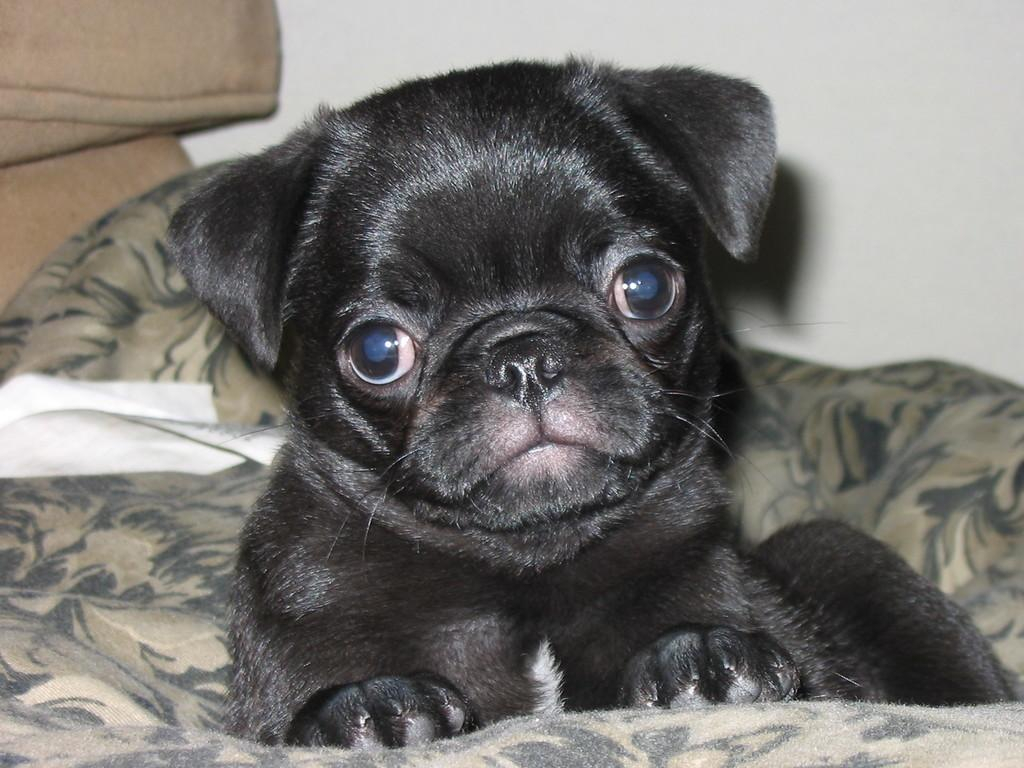What is the color of the wall in the image? The wall in the image is white. What type of animal can be seen in the image? There is a black color cat in the image. Where is the cat located in the image? The cat is sitting on a sofa. What type of pie is the cat eating on the branch in the image? There is no pie or branch present in the image; it features a black cat sitting on a sofa. How many bottles can be seen on the sofa with the cat? There are no bottles visible in the image; it only shows a black cat sitting on a sofa. 